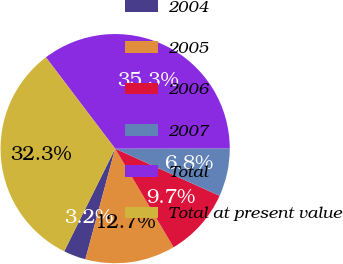Convert chart. <chart><loc_0><loc_0><loc_500><loc_500><pie_chart><fcel>2004<fcel>2005<fcel>2006<fcel>2007<fcel>Total<fcel>Total at present value<nl><fcel>3.15%<fcel>12.69%<fcel>9.74%<fcel>6.8%<fcel>35.28%<fcel>32.34%<nl></chart> 